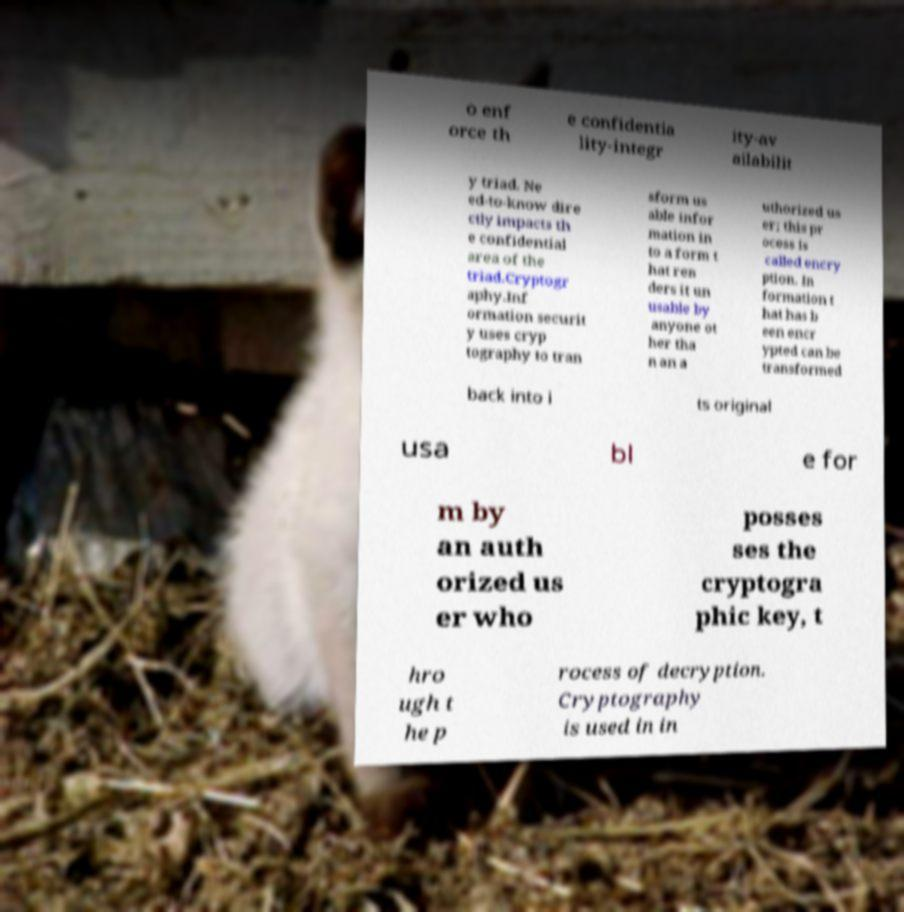Could you extract and type out the text from this image? o enf orce th e confidentia lity-integr ity-av ailabilit y triad. Ne ed-to-know dire ctly impacts th e confidential area of the triad.Cryptogr aphy.Inf ormation securit y uses cryp tography to tran sform us able infor mation in to a form t hat ren ders it un usable by anyone ot her tha n an a uthorized us er; this pr ocess is called encry ption. In formation t hat has b een encr ypted can be transformed back into i ts original usa bl e for m by an auth orized us er who posses ses the cryptogra phic key, t hro ugh t he p rocess of decryption. Cryptography is used in in 